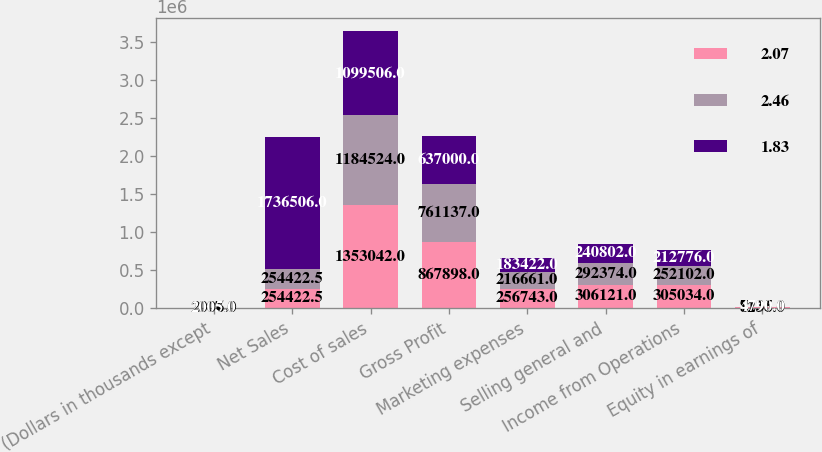Convert chart to OTSL. <chart><loc_0><loc_0><loc_500><loc_500><stacked_bar_chart><ecel><fcel>(Dollars in thousands except<fcel>Net Sales<fcel>Cost of sales<fcel>Gross Profit<fcel>Marketing expenses<fcel>Selling general and<fcel>Income from Operations<fcel>Equity in earnings of<nl><fcel>2.07<fcel>2007<fcel>254422<fcel>1.35304e+06<fcel>867898<fcel>256743<fcel>306121<fcel>305034<fcel>8236<nl><fcel>2.46<fcel>2006<fcel>254422<fcel>1.18452e+06<fcel>761137<fcel>216661<fcel>292374<fcel>252102<fcel>7135<nl><fcel>1.83<fcel>2005<fcel>1.73651e+06<fcel>1.09951e+06<fcel>637000<fcel>183422<fcel>240802<fcel>212776<fcel>4790<nl></chart> 